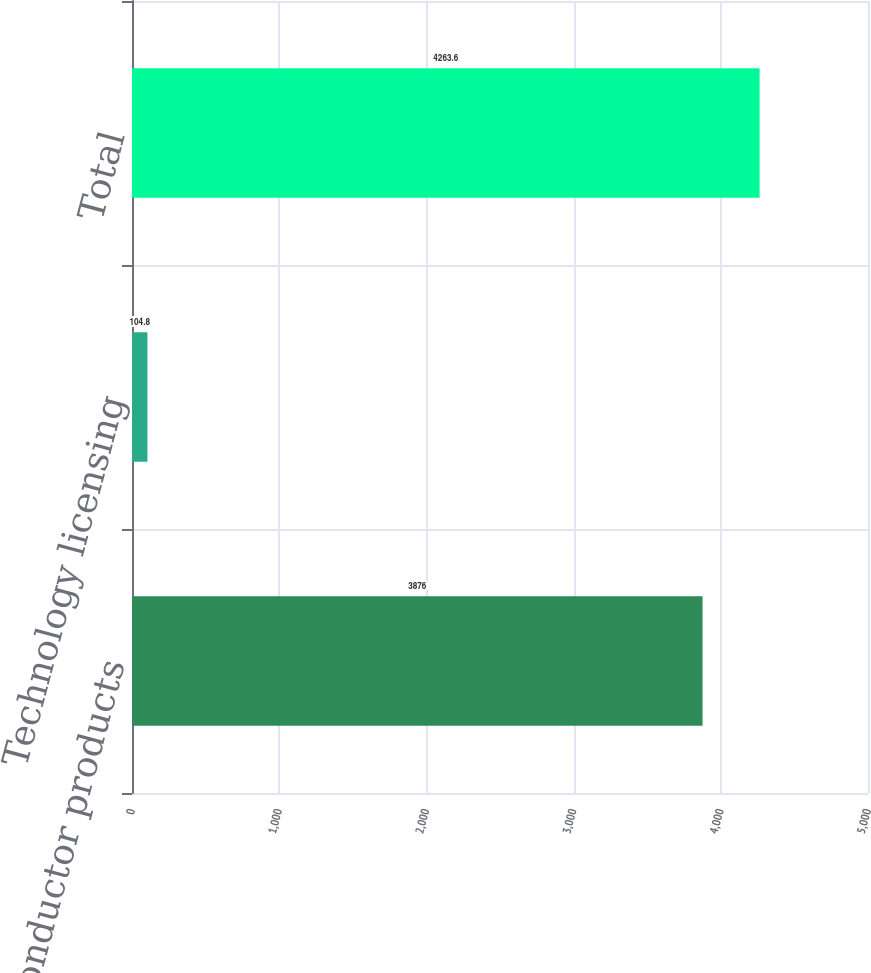Convert chart. <chart><loc_0><loc_0><loc_500><loc_500><bar_chart><fcel>Semiconductor products<fcel>Technology licensing<fcel>Total<nl><fcel>3876<fcel>104.8<fcel>4263.6<nl></chart> 